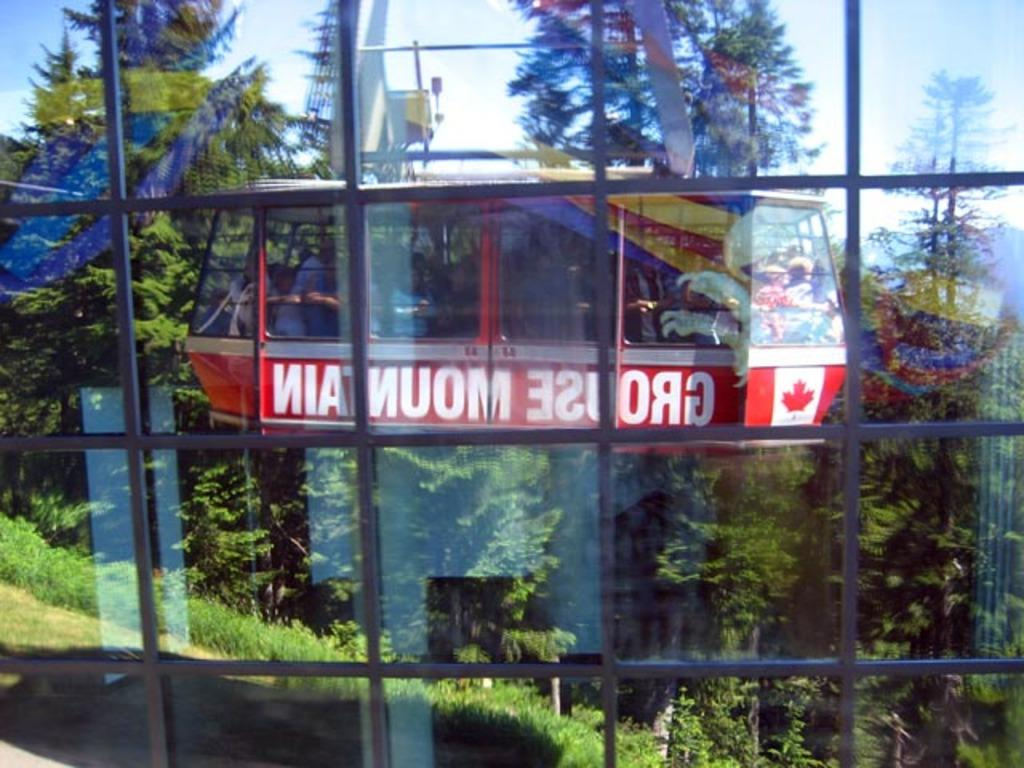<image>
Relay a brief, clear account of the picture shown. A reflection of Canadian sky ride looking outwards at a forest. 